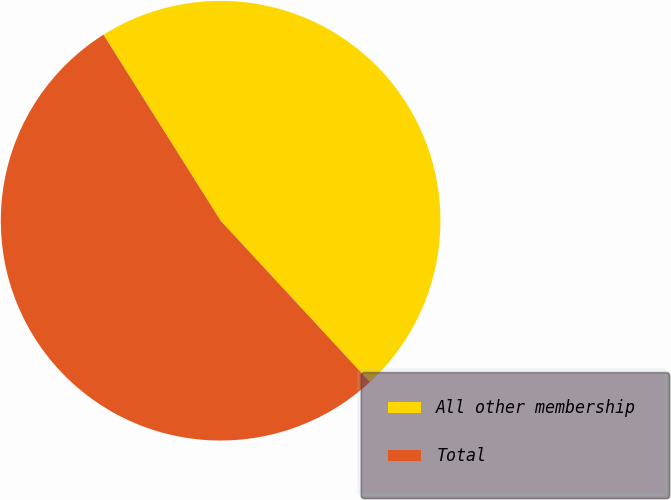Convert chart to OTSL. <chart><loc_0><loc_0><loc_500><loc_500><pie_chart><fcel>All other membership<fcel>Total<nl><fcel>47.06%<fcel>52.94%<nl></chart> 